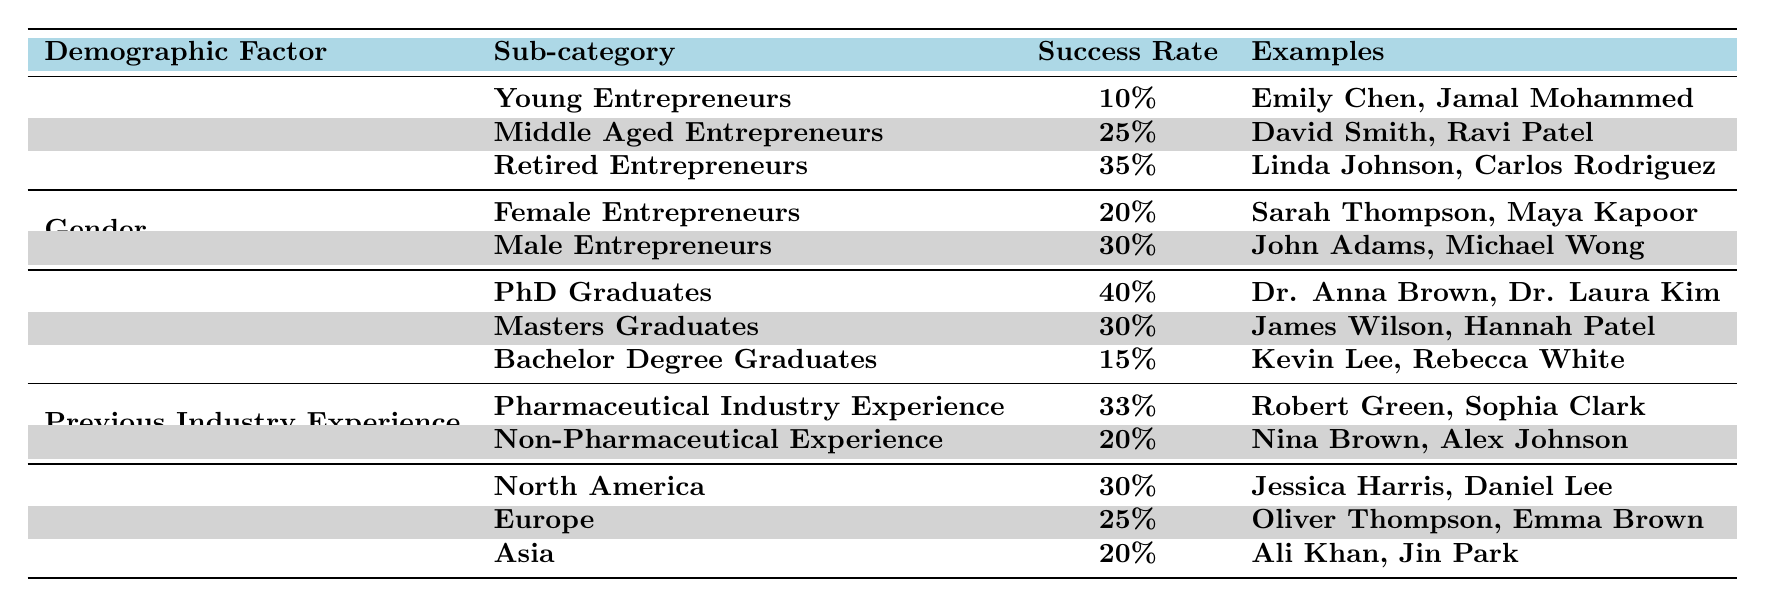What is the success rate for Retired Entrepreneurs? According to the table, the success rate for Retired Entrepreneurs is clearly stated as 35%.
Answer: 35% Which demographic group has the highest success rate? Upon examining the table, the group with the highest success rate is PhD Graduates, with a success rate of 40%.
Answer: PhD Graduates What is the success rate difference between Male and Female Entrepreneurs? The success rate for Male Entrepreneurs is 30%, while for Female Entrepreneurs it is 20%. The difference is calculated as 30% - 20% = 10%.
Answer: 10% Are Young Entrepreneurs more successful than Bachelor Degree Graduates? The success rate for Young Entrepreneurs is 10%, while for Bachelor Degree Graduates it is 15%. Therefore, Young Entrepreneurs are not more successful as their rate is lower.
Answer: No What is the average success rate for the Age Group demographic? The success rates for the Age Group are 10%, 25%, and 35%. To find the average, sum these values (10 + 25 + 35 = 70) and divide by the number of groups (3). The average is 70/3 = 23.33%.
Answer: 23.33% Which region has the lowest entrepreneurial success rate? The table lists the success rates for North America as 30%, Europe as 25%, and Asia as 20%. Asia has the lowest success rate at 20%.
Answer: Asia If you have a PhD and have experience in the Pharmaceutical industry, what is your success rate? The table indicates the success rate for PhD Graduates is 40% and for those with Pharmaceutical Industry Experience it is 33%. Since both factors compound, you would consider the higher value of 40%.
Answer: 40% What percentage of Female Entrepreneurs is successful compared to Middle Aged Entrepreneurs? Female Entrepreneurs have a success rate of 20%, while Middle Aged Entrepreneurs have a success rate of 25%. The comparison shows Middle Aged Entrepreneurs have a higher success rate.
Answer: Yes, Middle Aged Entrepreneurs have a higher success rate What is the total success rate of all the regions combined? The success rates for North America, Europe, and Asia are 30%, 25%, and 20%. To find the total, you add these three rates together (30 + 25 + 20 = 75). However, to find the average you divide the total by the number of regions (75/3 = 25).
Answer: 25% How many examples are provided for each sub-category in the Educational Background? The table provides two examples for PhD Graduates (Dr. Anna Brown, Dr. Laura Kim), two for Masters Graduates (James Wilson, Hannah Patel), and two for Bachelor Degree Graduates (Kevin Lee, Rebecca White), making a total of six.
Answer: 6 